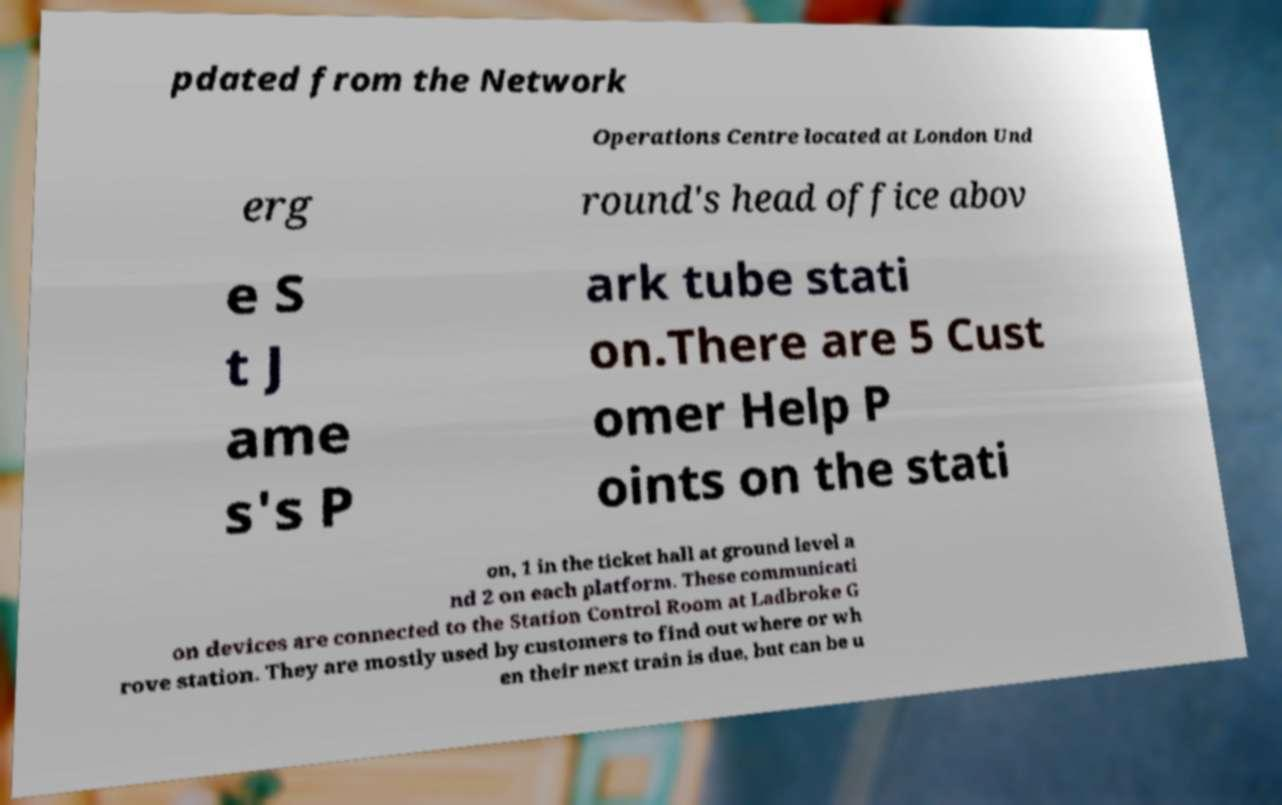Could you extract and type out the text from this image? pdated from the Network Operations Centre located at London Und erg round's head office abov e S t J ame s's P ark tube stati on.There are 5 Cust omer Help P oints on the stati on, 1 in the ticket hall at ground level a nd 2 on each platform. These communicati on devices are connected to the Station Control Room at Ladbroke G rove station. They are mostly used by customers to find out where or wh en their next train is due, but can be u 